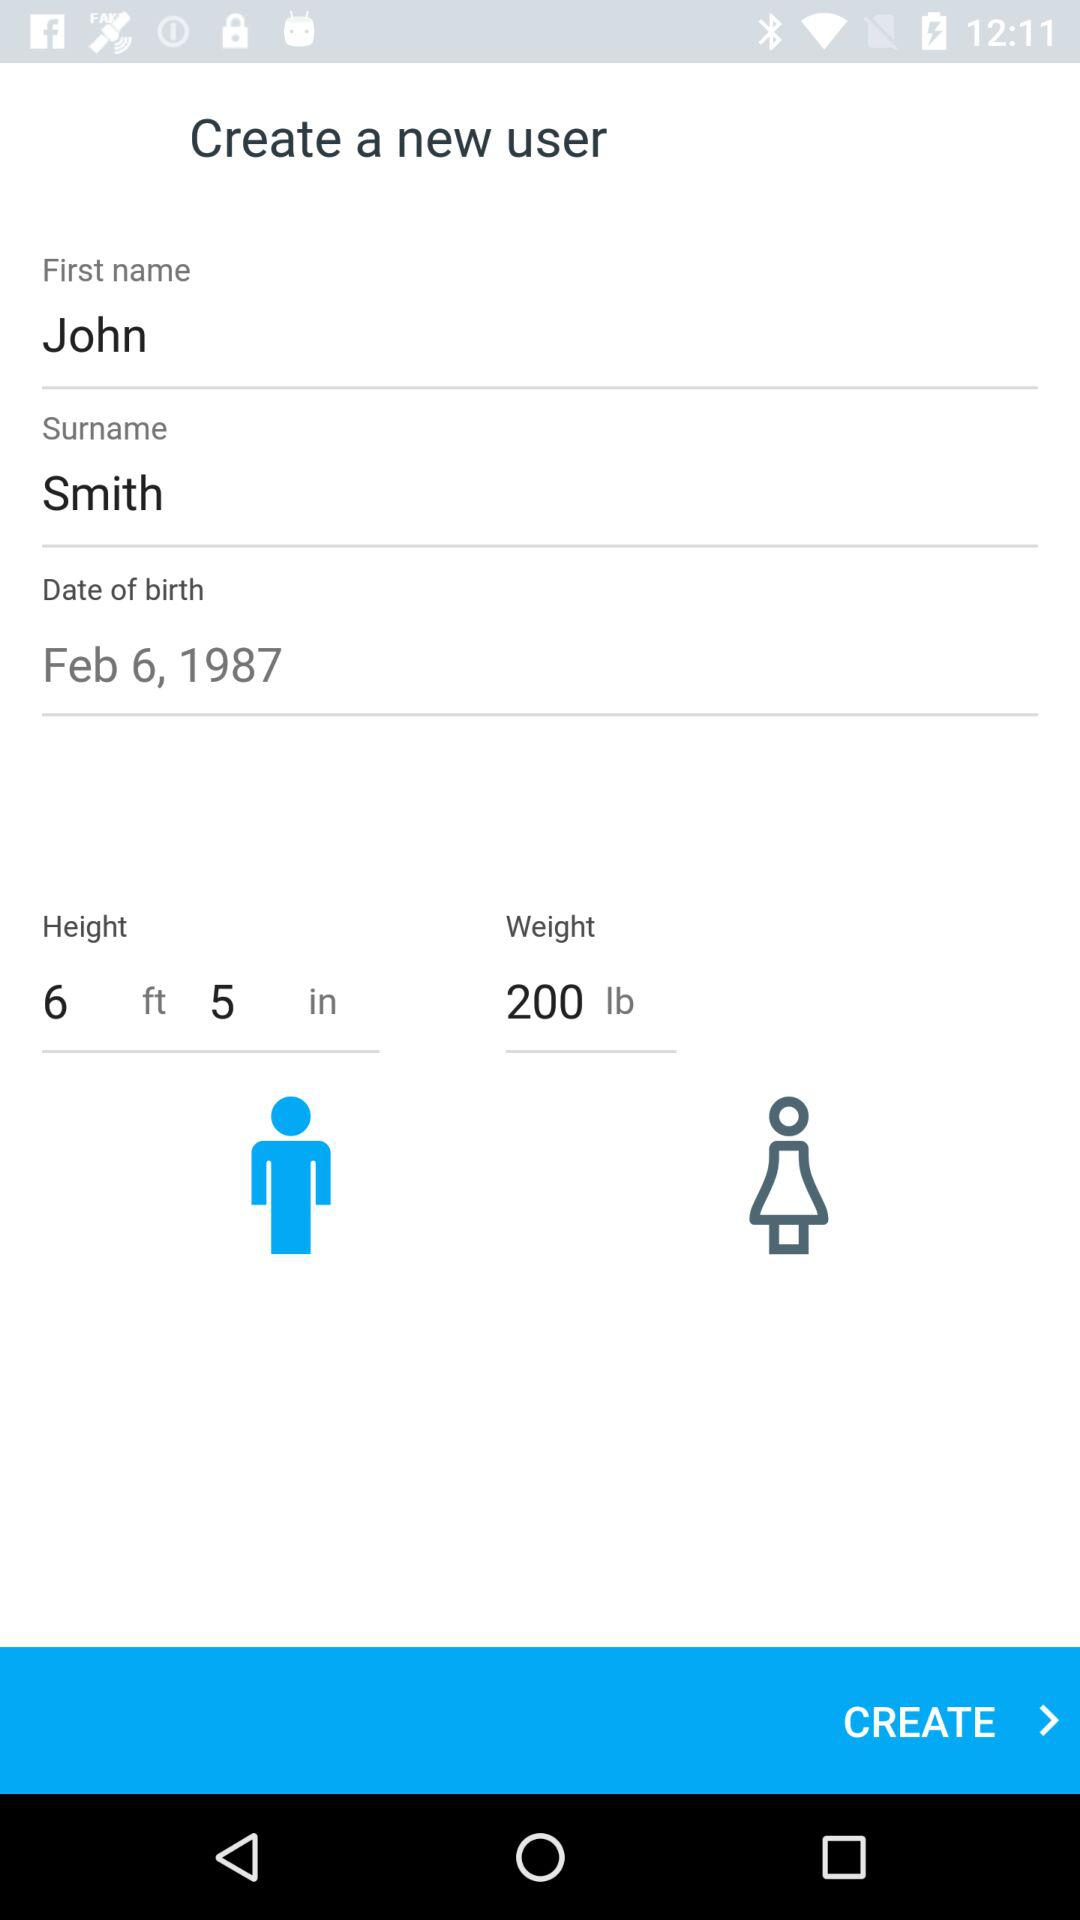What is the surname? The surname is Smith. 